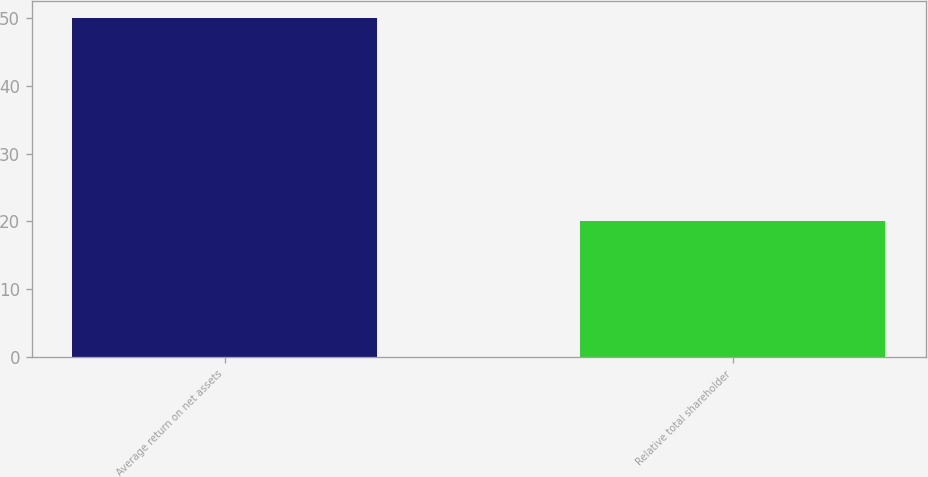<chart> <loc_0><loc_0><loc_500><loc_500><bar_chart><fcel>Average return on net assets<fcel>Relative total shareholder<nl><fcel>50<fcel>20<nl></chart> 